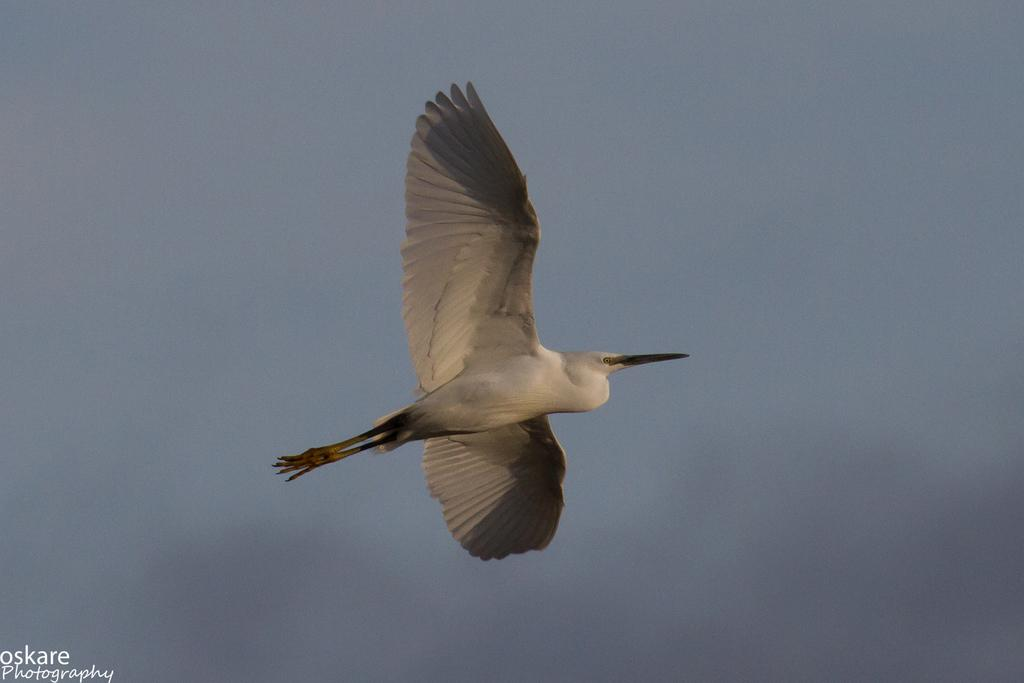What is the main subject of the image? There is a bird flying in the air in the center of the image. What can be seen in the background of the image? The sky is visible in the background of the image. How would you describe the sky in the image? The sky appears to be cloudy. Where is the text located in the image? The text is on the bottom left of the image. Can you tell me how many trails the bird is leaving behind in the image? There are no trails visible behind the bird in the image. What type of example does the bird provide in the image? The image does not present the bird as an example for any particular purpose. 